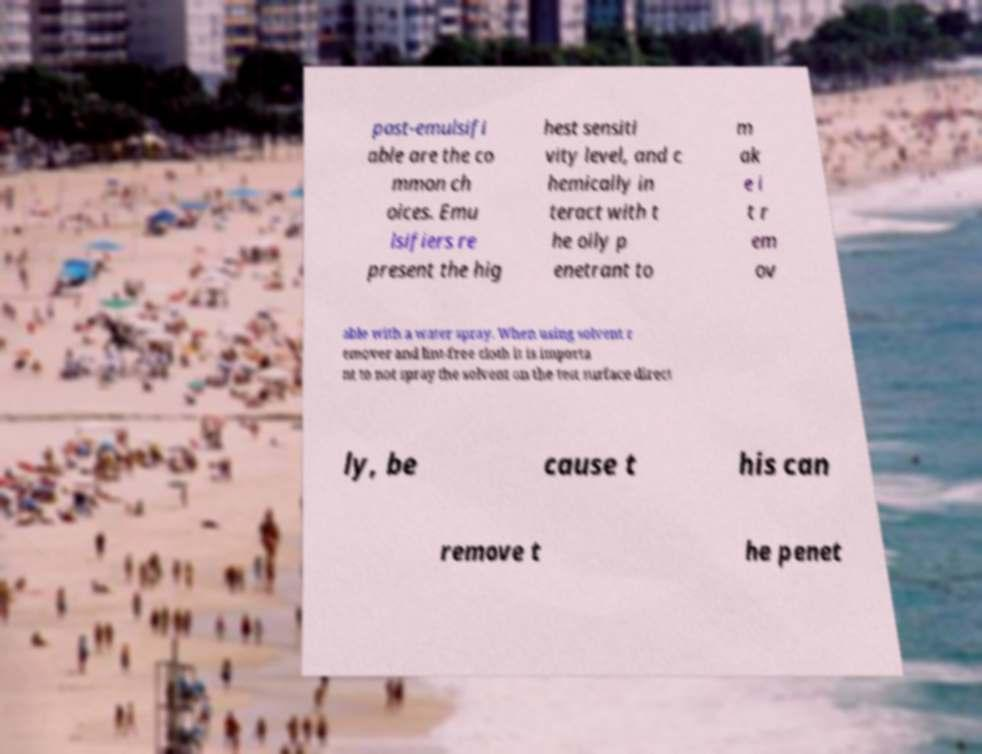Can you accurately transcribe the text from the provided image for me? post-emulsifi able are the co mmon ch oices. Emu lsifiers re present the hig hest sensiti vity level, and c hemically in teract with t he oily p enetrant to m ak e i t r em ov able with a water spray. When using solvent r emover and lint-free cloth it is importa nt to not spray the solvent on the test surface direct ly, be cause t his can remove t he penet 